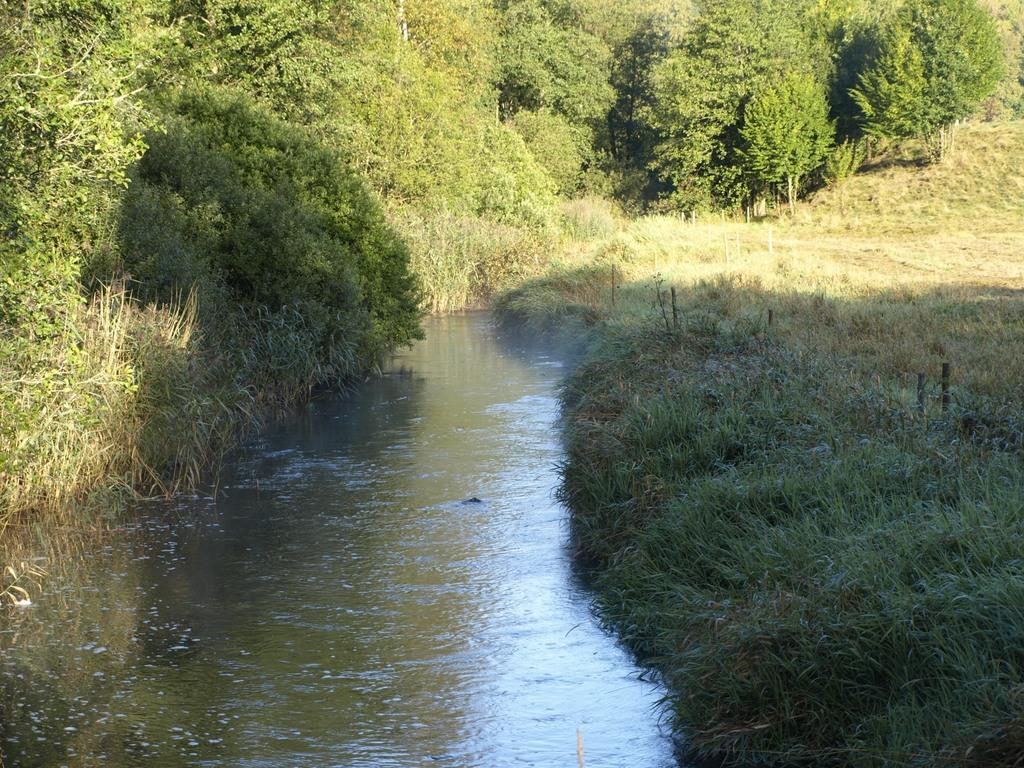What type of vegetation can be seen in the image? There are many trees and plants in the image. What type of ground cover is present in the image? There is grass in the image. What can be seen at the bottom of the image? There is water flow visible at the bottom of the image. What type of shirt is the man wearing in the image? There is no man present in the image, so it is not possible to determine what type of shirt he might be wearing. 